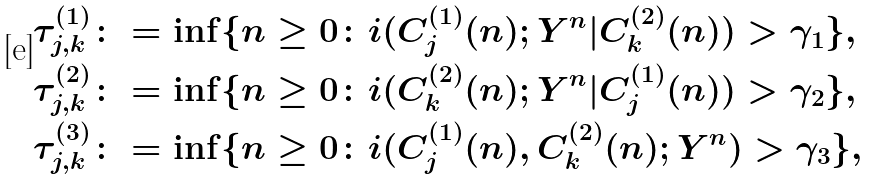Convert formula to latex. <formula><loc_0><loc_0><loc_500><loc_500>\tau ^ { ( 1 ) } _ { j , k } & \colon = \inf \{ n \geq 0 \colon i ( { C } ^ { ( 1 ) } _ { j } ( n ) ; Y ^ { n } | { C } ^ { ( 2 ) } _ { k } ( n ) ) > \gamma _ { 1 } \} , \\ \tau ^ { ( 2 ) } _ { j , k } & \colon = \inf \{ n \geq 0 \colon i ( { C } ^ { ( 2 ) } _ { k } ( n ) ; Y ^ { n } | { C } ^ { ( 1 ) } _ { j } ( n ) ) > \gamma _ { 2 } \} , \\ \tau ^ { ( 3 ) } _ { j , k } & \colon = \inf \{ n \geq 0 \colon i ( { C } ^ { ( 1 ) } _ { j } ( n ) , { C } ^ { ( 2 ) } _ { k } ( n ) ; Y ^ { n } ) > \gamma _ { 3 } \} ,</formula> 